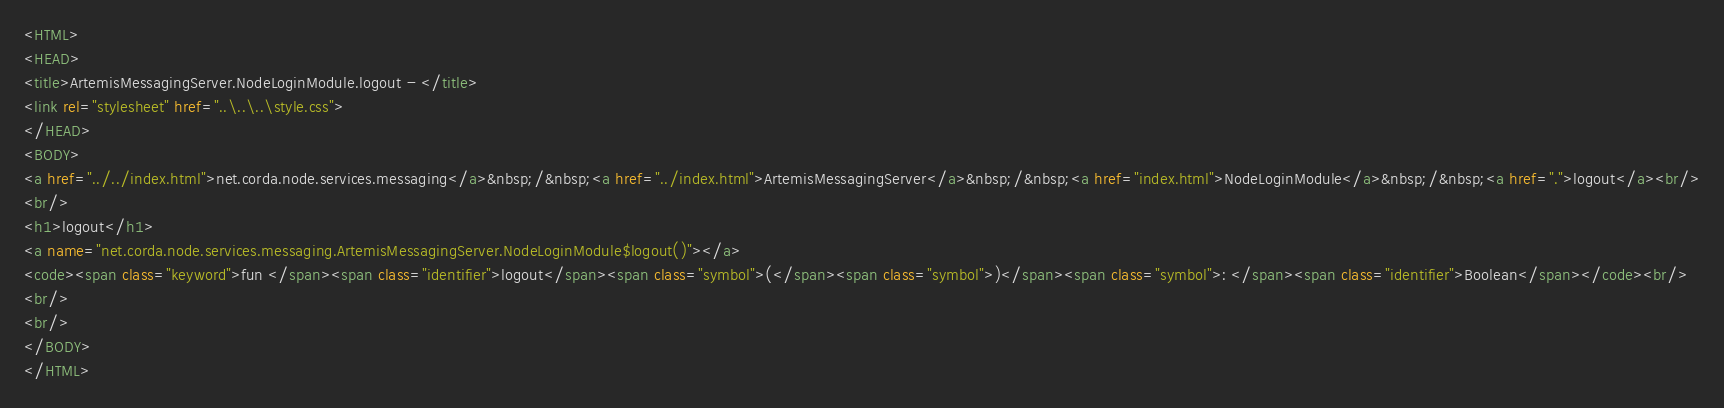<code> <loc_0><loc_0><loc_500><loc_500><_HTML_><HTML>
<HEAD>
<title>ArtemisMessagingServer.NodeLoginModule.logout - </title>
<link rel="stylesheet" href="..\..\..\style.css">
</HEAD>
<BODY>
<a href="../../index.html">net.corda.node.services.messaging</a>&nbsp;/&nbsp;<a href="../index.html">ArtemisMessagingServer</a>&nbsp;/&nbsp;<a href="index.html">NodeLoginModule</a>&nbsp;/&nbsp;<a href=".">logout</a><br/>
<br/>
<h1>logout</h1>
<a name="net.corda.node.services.messaging.ArtemisMessagingServer.NodeLoginModule$logout()"></a>
<code><span class="keyword">fun </span><span class="identifier">logout</span><span class="symbol">(</span><span class="symbol">)</span><span class="symbol">: </span><span class="identifier">Boolean</span></code><br/>
<br/>
<br/>
</BODY>
</HTML>
</code> 